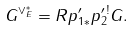<formula> <loc_0><loc_0><loc_500><loc_500>G ^ { \vee ^ { * } _ { E } } = R p ^ { \prime } _ { 1 * } p ^ { \prime \, ! } _ { 2 } G .</formula> 